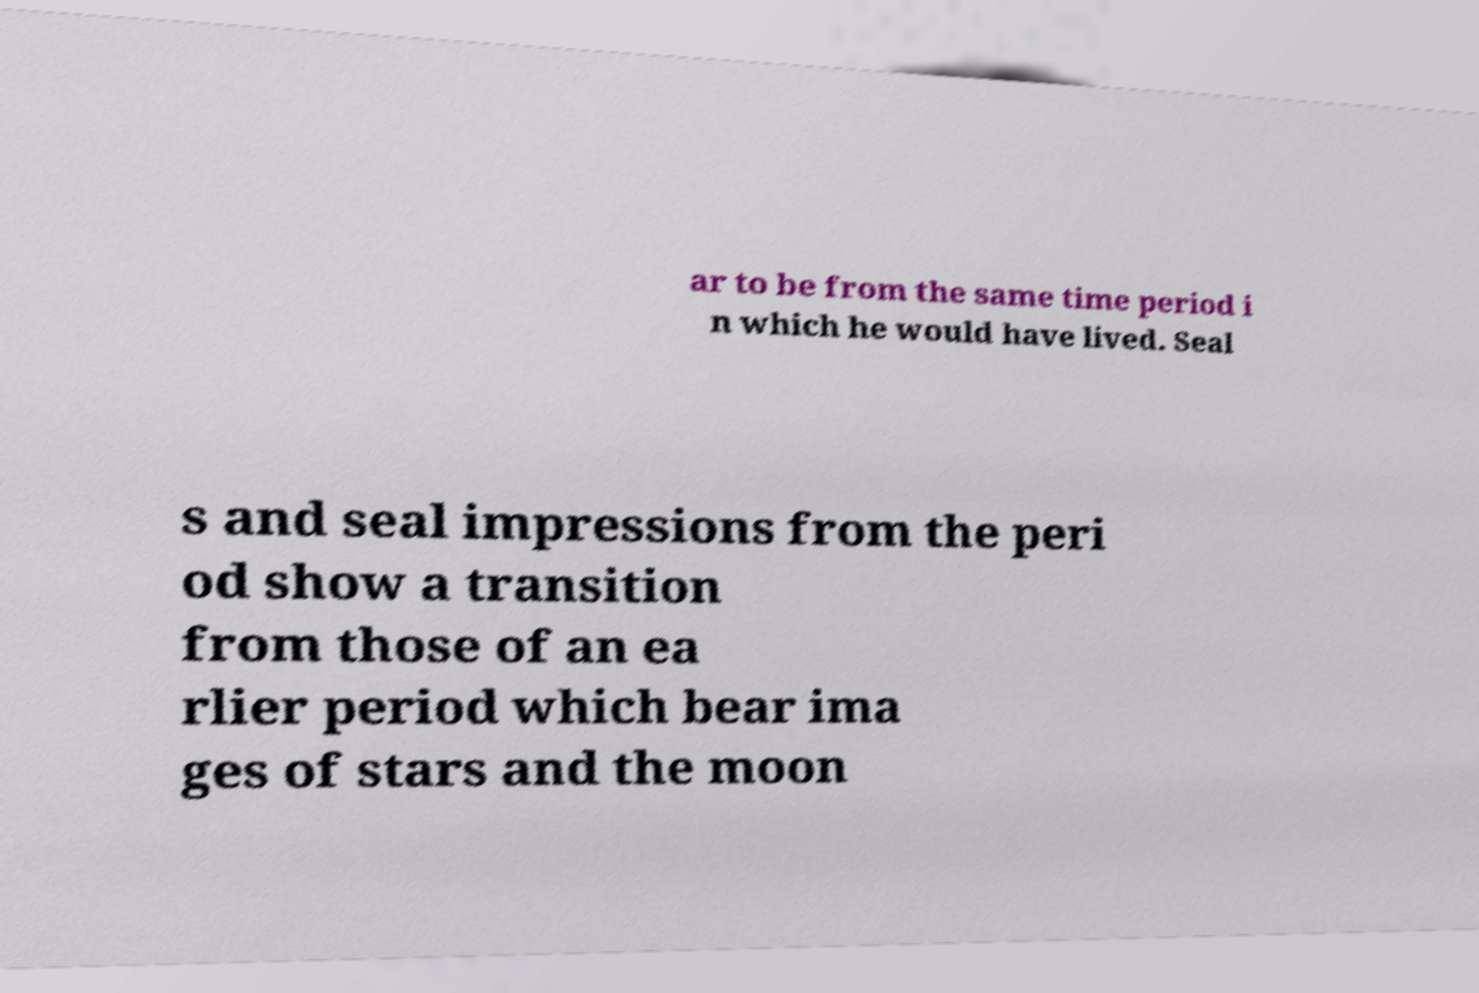Could you assist in decoding the text presented in this image and type it out clearly? ar to be from the same time period i n which he would have lived. Seal s and seal impressions from the peri od show a transition from those of an ea rlier period which bear ima ges of stars and the moon 